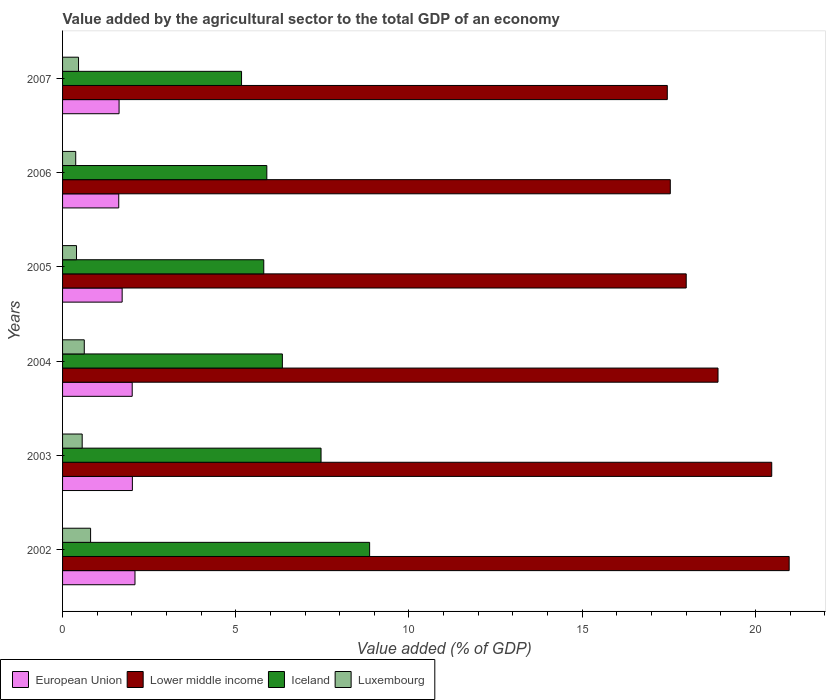How many groups of bars are there?
Your answer should be very brief. 6. How many bars are there on the 2nd tick from the top?
Your answer should be very brief. 4. How many bars are there on the 4th tick from the bottom?
Give a very brief answer. 4. What is the label of the 5th group of bars from the top?
Your answer should be very brief. 2003. What is the value added by the agricultural sector to the total GDP in Luxembourg in 2002?
Your answer should be very brief. 0.81. Across all years, what is the maximum value added by the agricultural sector to the total GDP in Luxembourg?
Provide a short and direct response. 0.81. Across all years, what is the minimum value added by the agricultural sector to the total GDP in Lower middle income?
Provide a short and direct response. 17.46. What is the total value added by the agricultural sector to the total GDP in Luxembourg in the graph?
Provide a succinct answer. 3.25. What is the difference between the value added by the agricultural sector to the total GDP in Luxembourg in 2005 and that in 2007?
Give a very brief answer. -0.06. What is the difference between the value added by the agricultural sector to the total GDP in Iceland in 2006 and the value added by the agricultural sector to the total GDP in Luxembourg in 2007?
Give a very brief answer. 5.44. What is the average value added by the agricultural sector to the total GDP in Iceland per year?
Your response must be concise. 6.59. In the year 2003, what is the difference between the value added by the agricultural sector to the total GDP in Lower middle income and value added by the agricultural sector to the total GDP in Iceland?
Provide a short and direct response. 13.01. What is the ratio of the value added by the agricultural sector to the total GDP in European Union in 2003 to that in 2006?
Your answer should be very brief. 1.24. Is the difference between the value added by the agricultural sector to the total GDP in Lower middle income in 2002 and 2005 greater than the difference between the value added by the agricultural sector to the total GDP in Iceland in 2002 and 2005?
Your answer should be very brief. No. What is the difference between the highest and the second highest value added by the agricultural sector to the total GDP in Luxembourg?
Give a very brief answer. 0.18. What is the difference between the highest and the lowest value added by the agricultural sector to the total GDP in European Union?
Give a very brief answer. 0.47. Is it the case that in every year, the sum of the value added by the agricultural sector to the total GDP in Lower middle income and value added by the agricultural sector to the total GDP in Luxembourg is greater than the sum of value added by the agricultural sector to the total GDP in European Union and value added by the agricultural sector to the total GDP in Iceland?
Your answer should be very brief. Yes. What does the 1st bar from the top in 2004 represents?
Offer a terse response. Luxembourg. What does the 4th bar from the bottom in 2003 represents?
Keep it short and to the point. Luxembourg. Is it the case that in every year, the sum of the value added by the agricultural sector to the total GDP in Iceland and value added by the agricultural sector to the total GDP in Luxembourg is greater than the value added by the agricultural sector to the total GDP in European Union?
Provide a succinct answer. Yes. How many bars are there?
Your answer should be compact. 24. Are all the bars in the graph horizontal?
Offer a very short reply. Yes. How many years are there in the graph?
Your response must be concise. 6. What is the difference between two consecutive major ticks on the X-axis?
Your answer should be compact. 5. Are the values on the major ticks of X-axis written in scientific E-notation?
Make the answer very short. No. Does the graph contain any zero values?
Your response must be concise. No. Does the graph contain grids?
Keep it short and to the point. No. How many legend labels are there?
Offer a terse response. 4. How are the legend labels stacked?
Provide a succinct answer. Horizontal. What is the title of the graph?
Your response must be concise. Value added by the agricultural sector to the total GDP of an economy. Does "Maldives" appear as one of the legend labels in the graph?
Provide a succinct answer. No. What is the label or title of the X-axis?
Keep it short and to the point. Value added (% of GDP). What is the Value added (% of GDP) of European Union in 2002?
Offer a very short reply. 2.09. What is the Value added (% of GDP) in Lower middle income in 2002?
Keep it short and to the point. 20.98. What is the Value added (% of GDP) in Iceland in 2002?
Offer a terse response. 8.86. What is the Value added (% of GDP) of Luxembourg in 2002?
Your answer should be very brief. 0.81. What is the Value added (% of GDP) of European Union in 2003?
Give a very brief answer. 2.02. What is the Value added (% of GDP) in Lower middle income in 2003?
Offer a very short reply. 20.47. What is the Value added (% of GDP) of Iceland in 2003?
Provide a succinct answer. 7.46. What is the Value added (% of GDP) of Luxembourg in 2003?
Ensure brevity in your answer.  0.57. What is the Value added (% of GDP) in European Union in 2004?
Your answer should be very brief. 2.01. What is the Value added (% of GDP) in Lower middle income in 2004?
Provide a short and direct response. 18.92. What is the Value added (% of GDP) in Iceland in 2004?
Provide a succinct answer. 6.35. What is the Value added (% of GDP) of Luxembourg in 2004?
Make the answer very short. 0.63. What is the Value added (% of GDP) in European Union in 2005?
Give a very brief answer. 1.72. What is the Value added (% of GDP) of Lower middle income in 2005?
Your response must be concise. 18. What is the Value added (% of GDP) in Iceland in 2005?
Make the answer very short. 5.81. What is the Value added (% of GDP) in Luxembourg in 2005?
Provide a succinct answer. 0.4. What is the Value added (% of GDP) of European Union in 2006?
Ensure brevity in your answer.  1.62. What is the Value added (% of GDP) in Lower middle income in 2006?
Give a very brief answer. 17.54. What is the Value added (% of GDP) in Iceland in 2006?
Make the answer very short. 5.9. What is the Value added (% of GDP) in Luxembourg in 2006?
Provide a short and direct response. 0.38. What is the Value added (% of GDP) in European Union in 2007?
Offer a very short reply. 1.63. What is the Value added (% of GDP) of Lower middle income in 2007?
Give a very brief answer. 17.46. What is the Value added (% of GDP) in Iceland in 2007?
Give a very brief answer. 5.17. What is the Value added (% of GDP) of Luxembourg in 2007?
Ensure brevity in your answer.  0.46. Across all years, what is the maximum Value added (% of GDP) in European Union?
Make the answer very short. 2.09. Across all years, what is the maximum Value added (% of GDP) in Lower middle income?
Your answer should be very brief. 20.98. Across all years, what is the maximum Value added (% of GDP) in Iceland?
Your answer should be compact. 8.86. Across all years, what is the maximum Value added (% of GDP) of Luxembourg?
Make the answer very short. 0.81. Across all years, what is the minimum Value added (% of GDP) of European Union?
Your response must be concise. 1.62. Across all years, what is the minimum Value added (% of GDP) of Lower middle income?
Give a very brief answer. 17.46. Across all years, what is the minimum Value added (% of GDP) in Iceland?
Provide a succinct answer. 5.17. Across all years, what is the minimum Value added (% of GDP) of Luxembourg?
Your answer should be compact. 0.38. What is the total Value added (% of GDP) in European Union in the graph?
Your answer should be very brief. 11.09. What is the total Value added (% of GDP) of Lower middle income in the graph?
Provide a short and direct response. 113.37. What is the total Value added (% of GDP) in Iceland in the graph?
Provide a succinct answer. 39.54. What is the total Value added (% of GDP) in Luxembourg in the graph?
Provide a short and direct response. 3.25. What is the difference between the Value added (% of GDP) of European Union in 2002 and that in 2003?
Your response must be concise. 0.08. What is the difference between the Value added (% of GDP) of Lower middle income in 2002 and that in 2003?
Keep it short and to the point. 0.5. What is the difference between the Value added (% of GDP) of Iceland in 2002 and that in 2003?
Make the answer very short. 1.4. What is the difference between the Value added (% of GDP) of Luxembourg in 2002 and that in 2003?
Your response must be concise. 0.24. What is the difference between the Value added (% of GDP) in European Union in 2002 and that in 2004?
Provide a short and direct response. 0.08. What is the difference between the Value added (% of GDP) in Lower middle income in 2002 and that in 2004?
Provide a short and direct response. 2.05. What is the difference between the Value added (% of GDP) in Iceland in 2002 and that in 2004?
Give a very brief answer. 2.52. What is the difference between the Value added (% of GDP) in Luxembourg in 2002 and that in 2004?
Offer a terse response. 0.18. What is the difference between the Value added (% of GDP) of European Union in 2002 and that in 2005?
Give a very brief answer. 0.37. What is the difference between the Value added (% of GDP) of Lower middle income in 2002 and that in 2005?
Your response must be concise. 2.97. What is the difference between the Value added (% of GDP) of Iceland in 2002 and that in 2005?
Keep it short and to the point. 3.06. What is the difference between the Value added (% of GDP) of Luxembourg in 2002 and that in 2005?
Keep it short and to the point. 0.41. What is the difference between the Value added (% of GDP) in European Union in 2002 and that in 2006?
Make the answer very short. 0.47. What is the difference between the Value added (% of GDP) in Lower middle income in 2002 and that in 2006?
Make the answer very short. 3.43. What is the difference between the Value added (% of GDP) of Iceland in 2002 and that in 2006?
Provide a succinct answer. 2.97. What is the difference between the Value added (% of GDP) of Luxembourg in 2002 and that in 2006?
Ensure brevity in your answer.  0.43. What is the difference between the Value added (% of GDP) in European Union in 2002 and that in 2007?
Offer a very short reply. 0.46. What is the difference between the Value added (% of GDP) in Lower middle income in 2002 and that in 2007?
Offer a very short reply. 3.52. What is the difference between the Value added (% of GDP) in Iceland in 2002 and that in 2007?
Your answer should be very brief. 3.7. What is the difference between the Value added (% of GDP) of Luxembourg in 2002 and that in 2007?
Your answer should be very brief. 0.35. What is the difference between the Value added (% of GDP) of European Union in 2003 and that in 2004?
Make the answer very short. 0. What is the difference between the Value added (% of GDP) in Lower middle income in 2003 and that in 2004?
Provide a succinct answer. 1.55. What is the difference between the Value added (% of GDP) in Iceland in 2003 and that in 2004?
Give a very brief answer. 1.12. What is the difference between the Value added (% of GDP) of Luxembourg in 2003 and that in 2004?
Offer a very short reply. -0.06. What is the difference between the Value added (% of GDP) in European Union in 2003 and that in 2005?
Make the answer very short. 0.29. What is the difference between the Value added (% of GDP) in Lower middle income in 2003 and that in 2005?
Provide a succinct answer. 2.47. What is the difference between the Value added (% of GDP) in Iceland in 2003 and that in 2005?
Your response must be concise. 1.65. What is the difference between the Value added (% of GDP) of Luxembourg in 2003 and that in 2005?
Keep it short and to the point. 0.16. What is the difference between the Value added (% of GDP) of European Union in 2003 and that in 2006?
Give a very brief answer. 0.39. What is the difference between the Value added (% of GDP) of Lower middle income in 2003 and that in 2006?
Give a very brief answer. 2.93. What is the difference between the Value added (% of GDP) of Iceland in 2003 and that in 2006?
Give a very brief answer. 1.57. What is the difference between the Value added (% of GDP) in Luxembourg in 2003 and that in 2006?
Provide a short and direct response. 0.19. What is the difference between the Value added (% of GDP) in European Union in 2003 and that in 2007?
Provide a short and direct response. 0.38. What is the difference between the Value added (% of GDP) of Lower middle income in 2003 and that in 2007?
Make the answer very short. 3.01. What is the difference between the Value added (% of GDP) in Iceland in 2003 and that in 2007?
Keep it short and to the point. 2.29. What is the difference between the Value added (% of GDP) in Luxembourg in 2003 and that in 2007?
Your answer should be compact. 0.11. What is the difference between the Value added (% of GDP) of European Union in 2004 and that in 2005?
Your answer should be very brief. 0.29. What is the difference between the Value added (% of GDP) of Lower middle income in 2004 and that in 2005?
Give a very brief answer. 0.92. What is the difference between the Value added (% of GDP) in Iceland in 2004 and that in 2005?
Offer a terse response. 0.54. What is the difference between the Value added (% of GDP) in Luxembourg in 2004 and that in 2005?
Keep it short and to the point. 0.22. What is the difference between the Value added (% of GDP) of European Union in 2004 and that in 2006?
Your response must be concise. 0.39. What is the difference between the Value added (% of GDP) in Lower middle income in 2004 and that in 2006?
Your response must be concise. 1.38. What is the difference between the Value added (% of GDP) of Iceland in 2004 and that in 2006?
Provide a short and direct response. 0.45. What is the difference between the Value added (% of GDP) of Luxembourg in 2004 and that in 2006?
Keep it short and to the point. 0.25. What is the difference between the Value added (% of GDP) in European Union in 2004 and that in 2007?
Your response must be concise. 0.38. What is the difference between the Value added (% of GDP) of Lower middle income in 2004 and that in 2007?
Ensure brevity in your answer.  1.46. What is the difference between the Value added (% of GDP) of Iceland in 2004 and that in 2007?
Your answer should be very brief. 1.18. What is the difference between the Value added (% of GDP) in Luxembourg in 2004 and that in 2007?
Your response must be concise. 0.17. What is the difference between the Value added (% of GDP) of European Union in 2005 and that in 2006?
Make the answer very short. 0.1. What is the difference between the Value added (% of GDP) in Lower middle income in 2005 and that in 2006?
Provide a succinct answer. 0.46. What is the difference between the Value added (% of GDP) of Iceland in 2005 and that in 2006?
Offer a very short reply. -0.09. What is the difference between the Value added (% of GDP) of Luxembourg in 2005 and that in 2006?
Your answer should be very brief. 0.02. What is the difference between the Value added (% of GDP) of European Union in 2005 and that in 2007?
Your answer should be very brief. 0.09. What is the difference between the Value added (% of GDP) of Lower middle income in 2005 and that in 2007?
Give a very brief answer. 0.55. What is the difference between the Value added (% of GDP) of Iceland in 2005 and that in 2007?
Your response must be concise. 0.64. What is the difference between the Value added (% of GDP) of Luxembourg in 2005 and that in 2007?
Offer a very short reply. -0.06. What is the difference between the Value added (% of GDP) of European Union in 2006 and that in 2007?
Ensure brevity in your answer.  -0.01. What is the difference between the Value added (% of GDP) of Lower middle income in 2006 and that in 2007?
Your answer should be very brief. 0.09. What is the difference between the Value added (% of GDP) in Iceland in 2006 and that in 2007?
Provide a succinct answer. 0.73. What is the difference between the Value added (% of GDP) of Luxembourg in 2006 and that in 2007?
Give a very brief answer. -0.08. What is the difference between the Value added (% of GDP) in European Union in 2002 and the Value added (% of GDP) in Lower middle income in 2003?
Give a very brief answer. -18.38. What is the difference between the Value added (% of GDP) in European Union in 2002 and the Value added (% of GDP) in Iceland in 2003?
Ensure brevity in your answer.  -5.37. What is the difference between the Value added (% of GDP) in European Union in 2002 and the Value added (% of GDP) in Luxembourg in 2003?
Make the answer very short. 1.52. What is the difference between the Value added (% of GDP) in Lower middle income in 2002 and the Value added (% of GDP) in Iceland in 2003?
Your answer should be very brief. 13.51. What is the difference between the Value added (% of GDP) of Lower middle income in 2002 and the Value added (% of GDP) of Luxembourg in 2003?
Ensure brevity in your answer.  20.41. What is the difference between the Value added (% of GDP) of Iceland in 2002 and the Value added (% of GDP) of Luxembourg in 2003?
Ensure brevity in your answer.  8.3. What is the difference between the Value added (% of GDP) of European Union in 2002 and the Value added (% of GDP) of Lower middle income in 2004?
Provide a short and direct response. -16.83. What is the difference between the Value added (% of GDP) in European Union in 2002 and the Value added (% of GDP) in Iceland in 2004?
Your answer should be very brief. -4.25. What is the difference between the Value added (% of GDP) of European Union in 2002 and the Value added (% of GDP) of Luxembourg in 2004?
Your answer should be very brief. 1.46. What is the difference between the Value added (% of GDP) in Lower middle income in 2002 and the Value added (% of GDP) in Iceland in 2004?
Make the answer very short. 14.63. What is the difference between the Value added (% of GDP) in Lower middle income in 2002 and the Value added (% of GDP) in Luxembourg in 2004?
Your answer should be compact. 20.35. What is the difference between the Value added (% of GDP) of Iceland in 2002 and the Value added (% of GDP) of Luxembourg in 2004?
Your answer should be very brief. 8.24. What is the difference between the Value added (% of GDP) in European Union in 2002 and the Value added (% of GDP) in Lower middle income in 2005?
Offer a very short reply. -15.91. What is the difference between the Value added (% of GDP) in European Union in 2002 and the Value added (% of GDP) in Iceland in 2005?
Offer a very short reply. -3.72. What is the difference between the Value added (% of GDP) in European Union in 2002 and the Value added (% of GDP) in Luxembourg in 2005?
Keep it short and to the point. 1.69. What is the difference between the Value added (% of GDP) of Lower middle income in 2002 and the Value added (% of GDP) of Iceland in 2005?
Provide a succinct answer. 15.17. What is the difference between the Value added (% of GDP) in Lower middle income in 2002 and the Value added (% of GDP) in Luxembourg in 2005?
Give a very brief answer. 20.57. What is the difference between the Value added (% of GDP) of Iceland in 2002 and the Value added (% of GDP) of Luxembourg in 2005?
Provide a short and direct response. 8.46. What is the difference between the Value added (% of GDP) of European Union in 2002 and the Value added (% of GDP) of Lower middle income in 2006?
Provide a succinct answer. -15.45. What is the difference between the Value added (% of GDP) of European Union in 2002 and the Value added (% of GDP) of Iceland in 2006?
Provide a short and direct response. -3.81. What is the difference between the Value added (% of GDP) of European Union in 2002 and the Value added (% of GDP) of Luxembourg in 2006?
Ensure brevity in your answer.  1.71. What is the difference between the Value added (% of GDP) of Lower middle income in 2002 and the Value added (% of GDP) of Iceland in 2006?
Make the answer very short. 15.08. What is the difference between the Value added (% of GDP) of Lower middle income in 2002 and the Value added (% of GDP) of Luxembourg in 2006?
Your answer should be very brief. 20.6. What is the difference between the Value added (% of GDP) of Iceland in 2002 and the Value added (% of GDP) of Luxembourg in 2006?
Your answer should be very brief. 8.48. What is the difference between the Value added (% of GDP) of European Union in 2002 and the Value added (% of GDP) of Lower middle income in 2007?
Make the answer very short. -15.37. What is the difference between the Value added (% of GDP) of European Union in 2002 and the Value added (% of GDP) of Iceland in 2007?
Make the answer very short. -3.08. What is the difference between the Value added (% of GDP) of European Union in 2002 and the Value added (% of GDP) of Luxembourg in 2007?
Give a very brief answer. 1.63. What is the difference between the Value added (% of GDP) in Lower middle income in 2002 and the Value added (% of GDP) in Iceland in 2007?
Give a very brief answer. 15.81. What is the difference between the Value added (% of GDP) in Lower middle income in 2002 and the Value added (% of GDP) in Luxembourg in 2007?
Ensure brevity in your answer.  20.51. What is the difference between the Value added (% of GDP) in Iceland in 2002 and the Value added (% of GDP) in Luxembourg in 2007?
Provide a succinct answer. 8.4. What is the difference between the Value added (% of GDP) in European Union in 2003 and the Value added (% of GDP) in Lower middle income in 2004?
Keep it short and to the point. -16.91. What is the difference between the Value added (% of GDP) of European Union in 2003 and the Value added (% of GDP) of Iceland in 2004?
Offer a terse response. -4.33. What is the difference between the Value added (% of GDP) in European Union in 2003 and the Value added (% of GDP) in Luxembourg in 2004?
Your answer should be very brief. 1.39. What is the difference between the Value added (% of GDP) in Lower middle income in 2003 and the Value added (% of GDP) in Iceland in 2004?
Your response must be concise. 14.13. What is the difference between the Value added (% of GDP) in Lower middle income in 2003 and the Value added (% of GDP) in Luxembourg in 2004?
Give a very brief answer. 19.85. What is the difference between the Value added (% of GDP) in Iceland in 2003 and the Value added (% of GDP) in Luxembourg in 2004?
Provide a succinct answer. 6.84. What is the difference between the Value added (% of GDP) in European Union in 2003 and the Value added (% of GDP) in Lower middle income in 2005?
Make the answer very short. -15.99. What is the difference between the Value added (% of GDP) in European Union in 2003 and the Value added (% of GDP) in Iceland in 2005?
Provide a succinct answer. -3.79. What is the difference between the Value added (% of GDP) in European Union in 2003 and the Value added (% of GDP) in Luxembourg in 2005?
Your answer should be compact. 1.61. What is the difference between the Value added (% of GDP) of Lower middle income in 2003 and the Value added (% of GDP) of Iceland in 2005?
Offer a terse response. 14.66. What is the difference between the Value added (% of GDP) of Lower middle income in 2003 and the Value added (% of GDP) of Luxembourg in 2005?
Ensure brevity in your answer.  20.07. What is the difference between the Value added (% of GDP) of Iceland in 2003 and the Value added (% of GDP) of Luxembourg in 2005?
Offer a very short reply. 7.06. What is the difference between the Value added (% of GDP) in European Union in 2003 and the Value added (% of GDP) in Lower middle income in 2006?
Offer a very short reply. -15.53. What is the difference between the Value added (% of GDP) of European Union in 2003 and the Value added (% of GDP) of Iceland in 2006?
Your response must be concise. -3.88. What is the difference between the Value added (% of GDP) of European Union in 2003 and the Value added (% of GDP) of Luxembourg in 2006?
Ensure brevity in your answer.  1.64. What is the difference between the Value added (% of GDP) in Lower middle income in 2003 and the Value added (% of GDP) in Iceland in 2006?
Offer a very short reply. 14.58. What is the difference between the Value added (% of GDP) of Lower middle income in 2003 and the Value added (% of GDP) of Luxembourg in 2006?
Keep it short and to the point. 20.09. What is the difference between the Value added (% of GDP) of Iceland in 2003 and the Value added (% of GDP) of Luxembourg in 2006?
Make the answer very short. 7.08. What is the difference between the Value added (% of GDP) in European Union in 2003 and the Value added (% of GDP) in Lower middle income in 2007?
Your answer should be very brief. -15.44. What is the difference between the Value added (% of GDP) of European Union in 2003 and the Value added (% of GDP) of Iceland in 2007?
Provide a succinct answer. -3.15. What is the difference between the Value added (% of GDP) in European Union in 2003 and the Value added (% of GDP) in Luxembourg in 2007?
Offer a terse response. 1.55. What is the difference between the Value added (% of GDP) in Lower middle income in 2003 and the Value added (% of GDP) in Iceland in 2007?
Give a very brief answer. 15.31. What is the difference between the Value added (% of GDP) of Lower middle income in 2003 and the Value added (% of GDP) of Luxembourg in 2007?
Keep it short and to the point. 20.01. What is the difference between the Value added (% of GDP) in Iceland in 2003 and the Value added (% of GDP) in Luxembourg in 2007?
Your answer should be very brief. 7. What is the difference between the Value added (% of GDP) of European Union in 2004 and the Value added (% of GDP) of Lower middle income in 2005?
Offer a terse response. -15.99. What is the difference between the Value added (% of GDP) in European Union in 2004 and the Value added (% of GDP) in Iceland in 2005?
Provide a short and direct response. -3.8. What is the difference between the Value added (% of GDP) in European Union in 2004 and the Value added (% of GDP) in Luxembourg in 2005?
Your response must be concise. 1.61. What is the difference between the Value added (% of GDP) in Lower middle income in 2004 and the Value added (% of GDP) in Iceland in 2005?
Provide a short and direct response. 13.11. What is the difference between the Value added (% of GDP) in Lower middle income in 2004 and the Value added (% of GDP) in Luxembourg in 2005?
Provide a short and direct response. 18.52. What is the difference between the Value added (% of GDP) of Iceland in 2004 and the Value added (% of GDP) of Luxembourg in 2005?
Offer a terse response. 5.94. What is the difference between the Value added (% of GDP) in European Union in 2004 and the Value added (% of GDP) in Lower middle income in 2006?
Your answer should be very brief. -15.53. What is the difference between the Value added (% of GDP) of European Union in 2004 and the Value added (% of GDP) of Iceland in 2006?
Ensure brevity in your answer.  -3.89. What is the difference between the Value added (% of GDP) in European Union in 2004 and the Value added (% of GDP) in Luxembourg in 2006?
Provide a short and direct response. 1.63. What is the difference between the Value added (% of GDP) of Lower middle income in 2004 and the Value added (% of GDP) of Iceland in 2006?
Offer a terse response. 13.02. What is the difference between the Value added (% of GDP) of Lower middle income in 2004 and the Value added (% of GDP) of Luxembourg in 2006?
Offer a very short reply. 18.54. What is the difference between the Value added (% of GDP) in Iceland in 2004 and the Value added (% of GDP) in Luxembourg in 2006?
Your response must be concise. 5.97. What is the difference between the Value added (% of GDP) of European Union in 2004 and the Value added (% of GDP) of Lower middle income in 2007?
Provide a short and direct response. -15.45. What is the difference between the Value added (% of GDP) of European Union in 2004 and the Value added (% of GDP) of Iceland in 2007?
Keep it short and to the point. -3.16. What is the difference between the Value added (% of GDP) of European Union in 2004 and the Value added (% of GDP) of Luxembourg in 2007?
Provide a short and direct response. 1.55. What is the difference between the Value added (% of GDP) of Lower middle income in 2004 and the Value added (% of GDP) of Iceland in 2007?
Keep it short and to the point. 13.75. What is the difference between the Value added (% of GDP) in Lower middle income in 2004 and the Value added (% of GDP) in Luxembourg in 2007?
Your response must be concise. 18.46. What is the difference between the Value added (% of GDP) of Iceland in 2004 and the Value added (% of GDP) of Luxembourg in 2007?
Your answer should be very brief. 5.88. What is the difference between the Value added (% of GDP) of European Union in 2005 and the Value added (% of GDP) of Lower middle income in 2006?
Give a very brief answer. -15.82. What is the difference between the Value added (% of GDP) in European Union in 2005 and the Value added (% of GDP) in Iceland in 2006?
Offer a terse response. -4.18. What is the difference between the Value added (% of GDP) in European Union in 2005 and the Value added (% of GDP) in Luxembourg in 2006?
Provide a succinct answer. 1.34. What is the difference between the Value added (% of GDP) in Lower middle income in 2005 and the Value added (% of GDP) in Iceland in 2006?
Offer a terse response. 12.11. What is the difference between the Value added (% of GDP) in Lower middle income in 2005 and the Value added (% of GDP) in Luxembourg in 2006?
Offer a terse response. 17.62. What is the difference between the Value added (% of GDP) of Iceland in 2005 and the Value added (% of GDP) of Luxembourg in 2006?
Give a very brief answer. 5.43. What is the difference between the Value added (% of GDP) in European Union in 2005 and the Value added (% of GDP) in Lower middle income in 2007?
Make the answer very short. -15.74. What is the difference between the Value added (% of GDP) of European Union in 2005 and the Value added (% of GDP) of Iceland in 2007?
Give a very brief answer. -3.45. What is the difference between the Value added (% of GDP) of European Union in 2005 and the Value added (% of GDP) of Luxembourg in 2007?
Provide a succinct answer. 1.26. What is the difference between the Value added (% of GDP) of Lower middle income in 2005 and the Value added (% of GDP) of Iceland in 2007?
Offer a terse response. 12.84. What is the difference between the Value added (% of GDP) in Lower middle income in 2005 and the Value added (% of GDP) in Luxembourg in 2007?
Provide a short and direct response. 17.54. What is the difference between the Value added (% of GDP) in Iceland in 2005 and the Value added (% of GDP) in Luxembourg in 2007?
Ensure brevity in your answer.  5.35. What is the difference between the Value added (% of GDP) of European Union in 2006 and the Value added (% of GDP) of Lower middle income in 2007?
Make the answer very short. -15.84. What is the difference between the Value added (% of GDP) in European Union in 2006 and the Value added (% of GDP) in Iceland in 2007?
Offer a very short reply. -3.54. What is the difference between the Value added (% of GDP) in European Union in 2006 and the Value added (% of GDP) in Luxembourg in 2007?
Your response must be concise. 1.16. What is the difference between the Value added (% of GDP) in Lower middle income in 2006 and the Value added (% of GDP) in Iceland in 2007?
Offer a terse response. 12.38. What is the difference between the Value added (% of GDP) in Lower middle income in 2006 and the Value added (% of GDP) in Luxembourg in 2007?
Provide a short and direct response. 17.08. What is the difference between the Value added (% of GDP) of Iceland in 2006 and the Value added (% of GDP) of Luxembourg in 2007?
Keep it short and to the point. 5.44. What is the average Value added (% of GDP) in European Union per year?
Make the answer very short. 1.85. What is the average Value added (% of GDP) in Lower middle income per year?
Give a very brief answer. 18.9. What is the average Value added (% of GDP) of Iceland per year?
Provide a succinct answer. 6.59. What is the average Value added (% of GDP) of Luxembourg per year?
Provide a succinct answer. 0.54. In the year 2002, what is the difference between the Value added (% of GDP) of European Union and Value added (% of GDP) of Lower middle income?
Keep it short and to the point. -18.88. In the year 2002, what is the difference between the Value added (% of GDP) of European Union and Value added (% of GDP) of Iceland?
Offer a very short reply. -6.77. In the year 2002, what is the difference between the Value added (% of GDP) in European Union and Value added (% of GDP) in Luxembourg?
Make the answer very short. 1.28. In the year 2002, what is the difference between the Value added (% of GDP) of Lower middle income and Value added (% of GDP) of Iceland?
Make the answer very short. 12.11. In the year 2002, what is the difference between the Value added (% of GDP) of Lower middle income and Value added (% of GDP) of Luxembourg?
Your answer should be very brief. 20.17. In the year 2002, what is the difference between the Value added (% of GDP) of Iceland and Value added (% of GDP) of Luxembourg?
Offer a terse response. 8.05. In the year 2003, what is the difference between the Value added (% of GDP) of European Union and Value added (% of GDP) of Lower middle income?
Offer a very short reply. -18.46. In the year 2003, what is the difference between the Value added (% of GDP) in European Union and Value added (% of GDP) in Iceland?
Give a very brief answer. -5.45. In the year 2003, what is the difference between the Value added (% of GDP) of European Union and Value added (% of GDP) of Luxembourg?
Ensure brevity in your answer.  1.45. In the year 2003, what is the difference between the Value added (% of GDP) in Lower middle income and Value added (% of GDP) in Iceland?
Your answer should be very brief. 13.01. In the year 2003, what is the difference between the Value added (% of GDP) of Lower middle income and Value added (% of GDP) of Luxembourg?
Offer a very short reply. 19.91. In the year 2003, what is the difference between the Value added (% of GDP) in Iceland and Value added (% of GDP) in Luxembourg?
Provide a short and direct response. 6.9. In the year 2004, what is the difference between the Value added (% of GDP) in European Union and Value added (% of GDP) in Lower middle income?
Provide a short and direct response. -16.91. In the year 2004, what is the difference between the Value added (% of GDP) in European Union and Value added (% of GDP) in Iceland?
Your answer should be very brief. -4.33. In the year 2004, what is the difference between the Value added (% of GDP) in European Union and Value added (% of GDP) in Luxembourg?
Your answer should be very brief. 1.38. In the year 2004, what is the difference between the Value added (% of GDP) in Lower middle income and Value added (% of GDP) in Iceland?
Keep it short and to the point. 12.58. In the year 2004, what is the difference between the Value added (% of GDP) of Lower middle income and Value added (% of GDP) of Luxembourg?
Offer a very short reply. 18.29. In the year 2004, what is the difference between the Value added (% of GDP) in Iceland and Value added (% of GDP) in Luxembourg?
Offer a terse response. 5.72. In the year 2005, what is the difference between the Value added (% of GDP) in European Union and Value added (% of GDP) in Lower middle income?
Offer a very short reply. -16.28. In the year 2005, what is the difference between the Value added (% of GDP) in European Union and Value added (% of GDP) in Iceland?
Offer a very short reply. -4.09. In the year 2005, what is the difference between the Value added (% of GDP) of European Union and Value added (% of GDP) of Luxembourg?
Offer a very short reply. 1.32. In the year 2005, what is the difference between the Value added (% of GDP) of Lower middle income and Value added (% of GDP) of Iceland?
Your response must be concise. 12.2. In the year 2005, what is the difference between the Value added (% of GDP) in Lower middle income and Value added (% of GDP) in Luxembourg?
Your answer should be compact. 17.6. In the year 2005, what is the difference between the Value added (% of GDP) in Iceland and Value added (% of GDP) in Luxembourg?
Make the answer very short. 5.41. In the year 2006, what is the difference between the Value added (% of GDP) of European Union and Value added (% of GDP) of Lower middle income?
Your response must be concise. -15.92. In the year 2006, what is the difference between the Value added (% of GDP) of European Union and Value added (% of GDP) of Iceland?
Give a very brief answer. -4.27. In the year 2006, what is the difference between the Value added (% of GDP) of European Union and Value added (% of GDP) of Luxembourg?
Offer a very short reply. 1.24. In the year 2006, what is the difference between the Value added (% of GDP) of Lower middle income and Value added (% of GDP) of Iceland?
Your answer should be very brief. 11.65. In the year 2006, what is the difference between the Value added (% of GDP) in Lower middle income and Value added (% of GDP) in Luxembourg?
Ensure brevity in your answer.  17.16. In the year 2006, what is the difference between the Value added (% of GDP) in Iceland and Value added (% of GDP) in Luxembourg?
Offer a very short reply. 5.52. In the year 2007, what is the difference between the Value added (% of GDP) in European Union and Value added (% of GDP) in Lower middle income?
Make the answer very short. -15.83. In the year 2007, what is the difference between the Value added (% of GDP) of European Union and Value added (% of GDP) of Iceland?
Offer a very short reply. -3.54. In the year 2007, what is the difference between the Value added (% of GDP) in European Union and Value added (% of GDP) in Luxembourg?
Your response must be concise. 1.17. In the year 2007, what is the difference between the Value added (% of GDP) in Lower middle income and Value added (% of GDP) in Iceland?
Provide a succinct answer. 12.29. In the year 2007, what is the difference between the Value added (% of GDP) of Lower middle income and Value added (% of GDP) of Luxembourg?
Offer a very short reply. 17. In the year 2007, what is the difference between the Value added (% of GDP) of Iceland and Value added (% of GDP) of Luxembourg?
Offer a very short reply. 4.71. What is the ratio of the Value added (% of GDP) in European Union in 2002 to that in 2003?
Provide a succinct answer. 1.04. What is the ratio of the Value added (% of GDP) of Lower middle income in 2002 to that in 2003?
Your response must be concise. 1.02. What is the ratio of the Value added (% of GDP) in Iceland in 2002 to that in 2003?
Your response must be concise. 1.19. What is the ratio of the Value added (% of GDP) in Luxembourg in 2002 to that in 2003?
Offer a very short reply. 1.43. What is the ratio of the Value added (% of GDP) in European Union in 2002 to that in 2004?
Provide a short and direct response. 1.04. What is the ratio of the Value added (% of GDP) of Lower middle income in 2002 to that in 2004?
Make the answer very short. 1.11. What is the ratio of the Value added (% of GDP) of Iceland in 2002 to that in 2004?
Provide a short and direct response. 1.4. What is the ratio of the Value added (% of GDP) of Luxembourg in 2002 to that in 2004?
Your response must be concise. 1.29. What is the ratio of the Value added (% of GDP) in European Union in 2002 to that in 2005?
Provide a succinct answer. 1.22. What is the ratio of the Value added (% of GDP) of Lower middle income in 2002 to that in 2005?
Your answer should be very brief. 1.17. What is the ratio of the Value added (% of GDP) of Iceland in 2002 to that in 2005?
Offer a terse response. 1.53. What is the ratio of the Value added (% of GDP) in Luxembourg in 2002 to that in 2005?
Offer a terse response. 2.01. What is the ratio of the Value added (% of GDP) of European Union in 2002 to that in 2006?
Provide a short and direct response. 1.29. What is the ratio of the Value added (% of GDP) of Lower middle income in 2002 to that in 2006?
Ensure brevity in your answer.  1.2. What is the ratio of the Value added (% of GDP) in Iceland in 2002 to that in 2006?
Provide a succinct answer. 1.5. What is the ratio of the Value added (% of GDP) of Luxembourg in 2002 to that in 2006?
Offer a terse response. 2.13. What is the ratio of the Value added (% of GDP) of European Union in 2002 to that in 2007?
Keep it short and to the point. 1.28. What is the ratio of the Value added (% of GDP) in Lower middle income in 2002 to that in 2007?
Offer a terse response. 1.2. What is the ratio of the Value added (% of GDP) of Iceland in 2002 to that in 2007?
Your response must be concise. 1.72. What is the ratio of the Value added (% of GDP) of Luxembourg in 2002 to that in 2007?
Your answer should be very brief. 1.75. What is the ratio of the Value added (% of GDP) of Lower middle income in 2003 to that in 2004?
Your response must be concise. 1.08. What is the ratio of the Value added (% of GDP) of Iceland in 2003 to that in 2004?
Keep it short and to the point. 1.18. What is the ratio of the Value added (% of GDP) in Luxembourg in 2003 to that in 2004?
Your answer should be very brief. 0.9. What is the ratio of the Value added (% of GDP) in European Union in 2003 to that in 2005?
Provide a succinct answer. 1.17. What is the ratio of the Value added (% of GDP) of Lower middle income in 2003 to that in 2005?
Your answer should be very brief. 1.14. What is the ratio of the Value added (% of GDP) of Iceland in 2003 to that in 2005?
Keep it short and to the point. 1.28. What is the ratio of the Value added (% of GDP) of Luxembourg in 2003 to that in 2005?
Your answer should be very brief. 1.41. What is the ratio of the Value added (% of GDP) of European Union in 2003 to that in 2006?
Ensure brevity in your answer.  1.24. What is the ratio of the Value added (% of GDP) of Lower middle income in 2003 to that in 2006?
Your response must be concise. 1.17. What is the ratio of the Value added (% of GDP) in Iceland in 2003 to that in 2006?
Provide a short and direct response. 1.27. What is the ratio of the Value added (% of GDP) of Luxembourg in 2003 to that in 2006?
Give a very brief answer. 1.49. What is the ratio of the Value added (% of GDP) in European Union in 2003 to that in 2007?
Offer a very short reply. 1.24. What is the ratio of the Value added (% of GDP) of Lower middle income in 2003 to that in 2007?
Ensure brevity in your answer.  1.17. What is the ratio of the Value added (% of GDP) of Iceland in 2003 to that in 2007?
Provide a succinct answer. 1.44. What is the ratio of the Value added (% of GDP) of Luxembourg in 2003 to that in 2007?
Offer a terse response. 1.23. What is the ratio of the Value added (% of GDP) of European Union in 2004 to that in 2005?
Offer a very short reply. 1.17. What is the ratio of the Value added (% of GDP) of Lower middle income in 2004 to that in 2005?
Make the answer very short. 1.05. What is the ratio of the Value added (% of GDP) of Iceland in 2004 to that in 2005?
Keep it short and to the point. 1.09. What is the ratio of the Value added (% of GDP) of Luxembourg in 2004 to that in 2005?
Offer a terse response. 1.56. What is the ratio of the Value added (% of GDP) in European Union in 2004 to that in 2006?
Provide a succinct answer. 1.24. What is the ratio of the Value added (% of GDP) of Lower middle income in 2004 to that in 2006?
Provide a succinct answer. 1.08. What is the ratio of the Value added (% of GDP) in Iceland in 2004 to that in 2006?
Your response must be concise. 1.08. What is the ratio of the Value added (% of GDP) in Luxembourg in 2004 to that in 2006?
Offer a terse response. 1.65. What is the ratio of the Value added (% of GDP) in European Union in 2004 to that in 2007?
Your answer should be compact. 1.23. What is the ratio of the Value added (% of GDP) in Lower middle income in 2004 to that in 2007?
Provide a short and direct response. 1.08. What is the ratio of the Value added (% of GDP) in Iceland in 2004 to that in 2007?
Give a very brief answer. 1.23. What is the ratio of the Value added (% of GDP) of Luxembourg in 2004 to that in 2007?
Make the answer very short. 1.36. What is the ratio of the Value added (% of GDP) of European Union in 2005 to that in 2006?
Offer a very short reply. 1.06. What is the ratio of the Value added (% of GDP) of Lower middle income in 2005 to that in 2006?
Provide a succinct answer. 1.03. What is the ratio of the Value added (% of GDP) of Iceland in 2005 to that in 2006?
Make the answer very short. 0.98. What is the ratio of the Value added (% of GDP) of Luxembourg in 2005 to that in 2006?
Give a very brief answer. 1.06. What is the ratio of the Value added (% of GDP) of European Union in 2005 to that in 2007?
Offer a very short reply. 1.05. What is the ratio of the Value added (% of GDP) of Lower middle income in 2005 to that in 2007?
Make the answer very short. 1.03. What is the ratio of the Value added (% of GDP) of Iceland in 2005 to that in 2007?
Ensure brevity in your answer.  1.12. What is the ratio of the Value added (% of GDP) of Luxembourg in 2005 to that in 2007?
Offer a very short reply. 0.87. What is the ratio of the Value added (% of GDP) in Iceland in 2006 to that in 2007?
Offer a terse response. 1.14. What is the ratio of the Value added (% of GDP) of Luxembourg in 2006 to that in 2007?
Make the answer very short. 0.82. What is the difference between the highest and the second highest Value added (% of GDP) in European Union?
Make the answer very short. 0.08. What is the difference between the highest and the second highest Value added (% of GDP) in Lower middle income?
Provide a short and direct response. 0.5. What is the difference between the highest and the second highest Value added (% of GDP) of Iceland?
Keep it short and to the point. 1.4. What is the difference between the highest and the second highest Value added (% of GDP) in Luxembourg?
Your answer should be compact. 0.18. What is the difference between the highest and the lowest Value added (% of GDP) of European Union?
Your answer should be very brief. 0.47. What is the difference between the highest and the lowest Value added (% of GDP) of Lower middle income?
Your response must be concise. 3.52. What is the difference between the highest and the lowest Value added (% of GDP) of Iceland?
Ensure brevity in your answer.  3.7. What is the difference between the highest and the lowest Value added (% of GDP) of Luxembourg?
Provide a short and direct response. 0.43. 